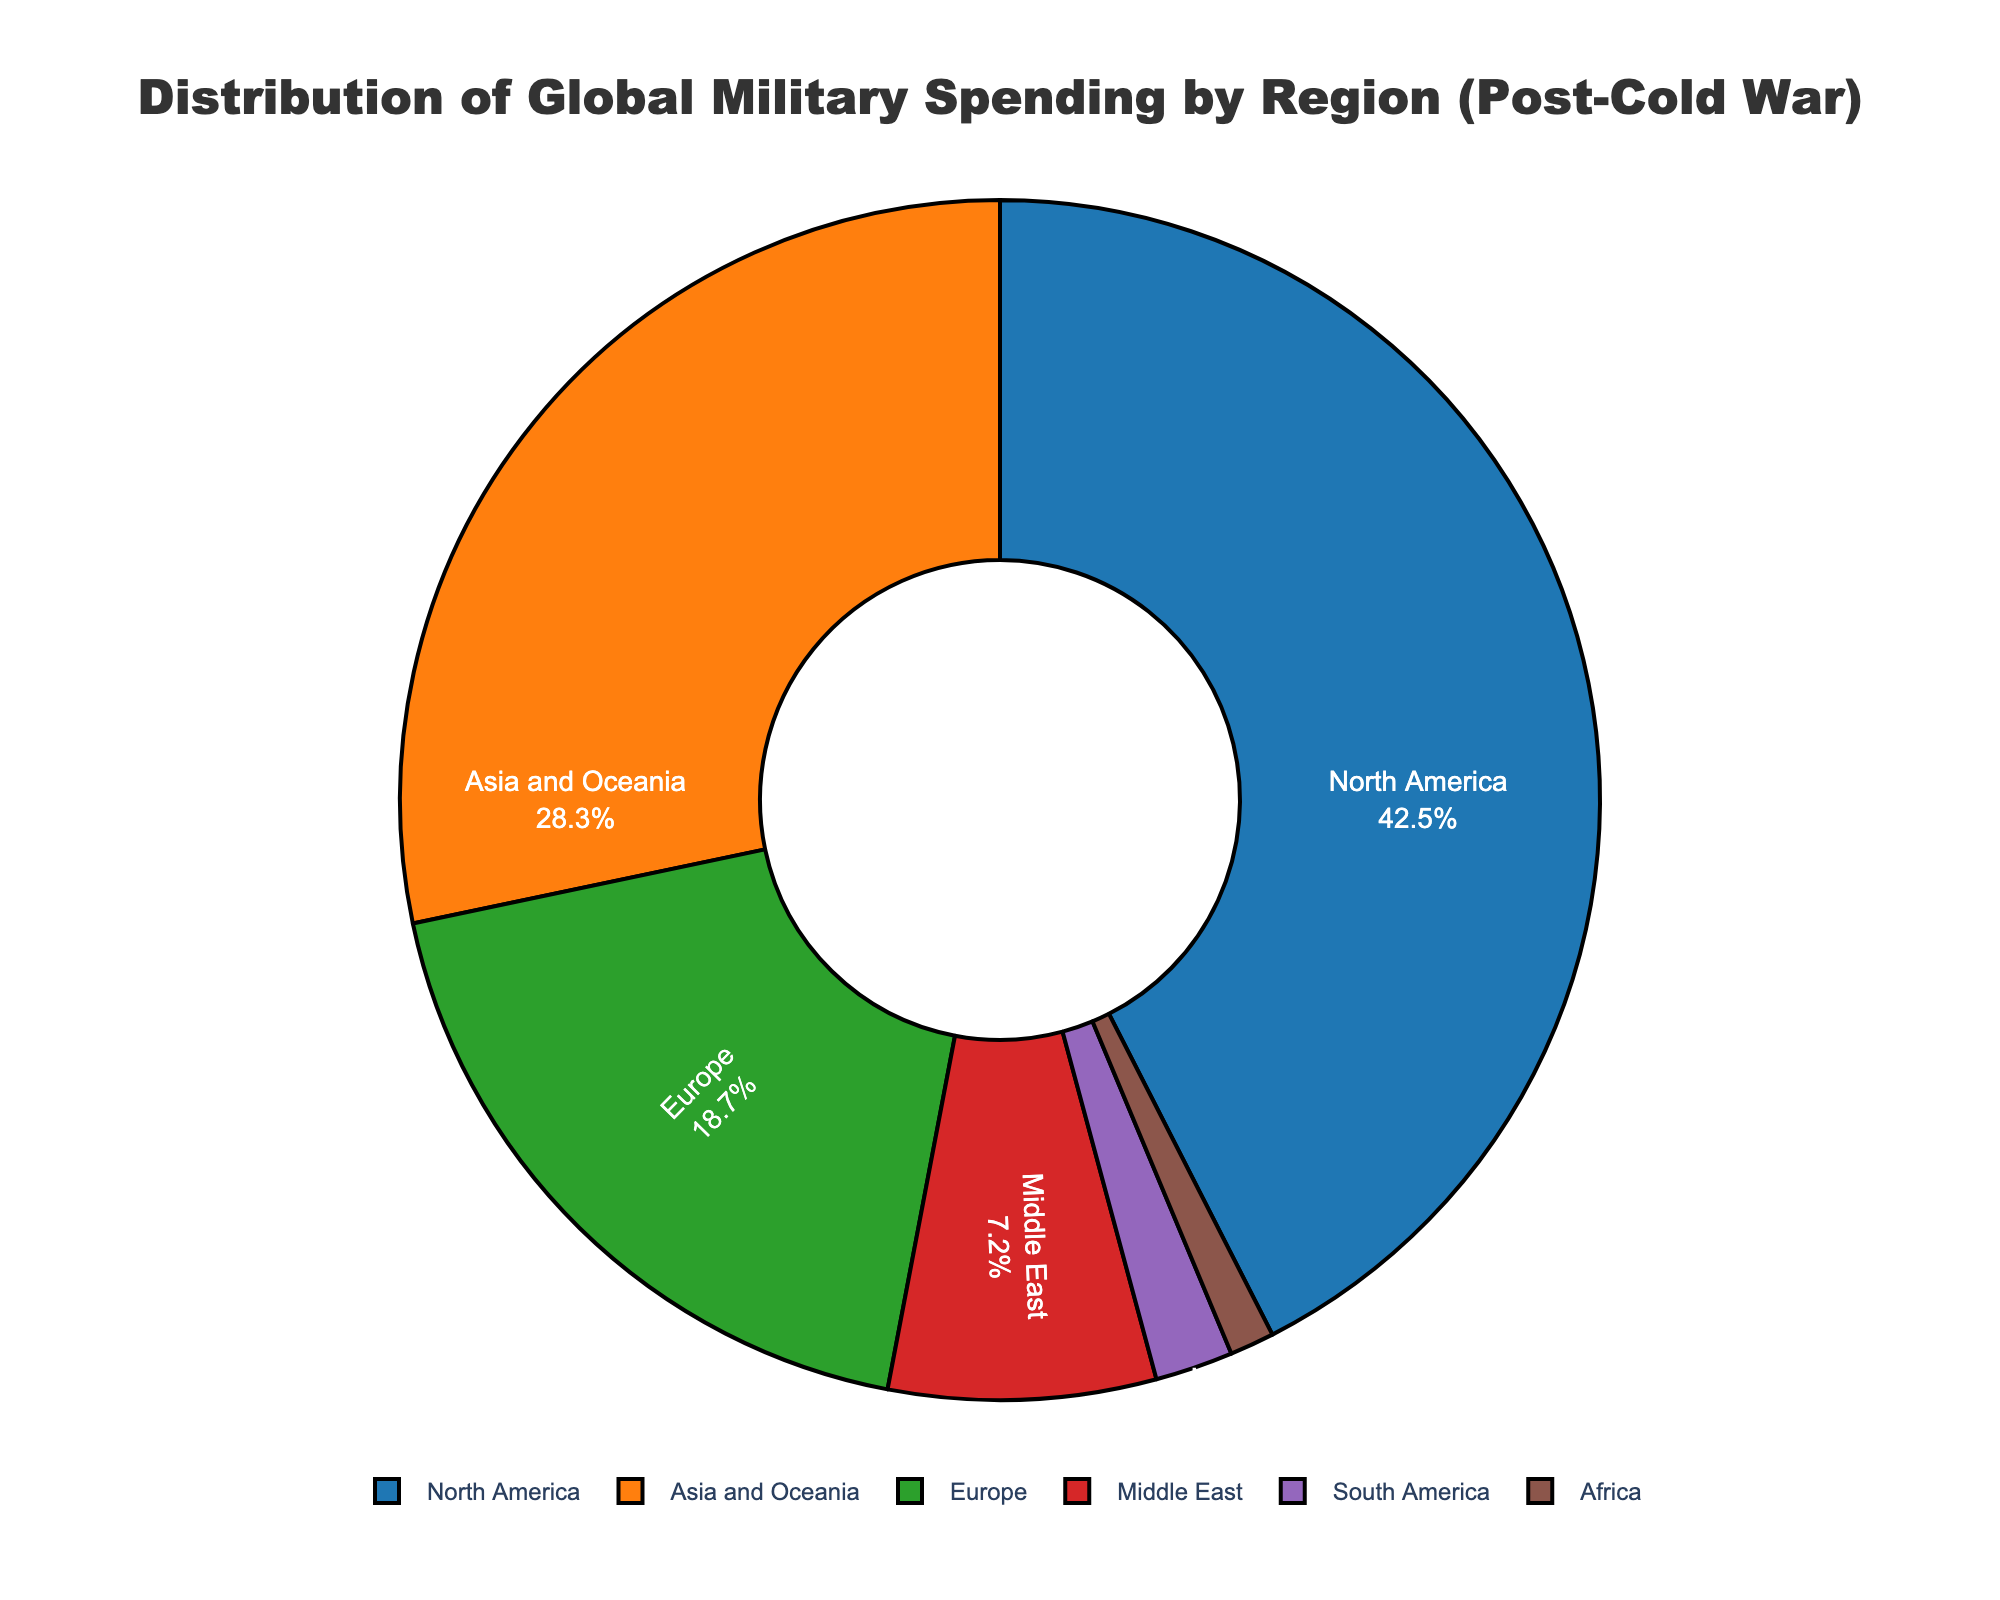Which region accounts for the largest share of global military spending? From the pie chart, the largest portion is represented by North America, which has a percentage of 42.5%. This is visually the largest segment.
Answer: North America What percentage of global military spending is attributed to Asia and Oceania? The chart displays the specific percentage for Asia and Oceania as 28.3%, visible in the segment of the pie chart labeled Asia and Oceania.
Answer: 28.3% How does Europe's share of global military spending compare to that of the Middle East? From the pie chart, Europe accounts for 18.7% while the Middle East accounts for 7.2%. Comparing these percentages visually and numerically, Europe's share is larger.
Answer: Europe's share is larger What is the combined percentage of global military spending for Africa, South America, and the Middle East? Adding the percentages from the pie chart: Africa (1.2%), South America (2.1%), and the Middle East (7.2%), the combined total is 1.2 + 2.1 + 7.2 = 10.5%.
Answer: 10.5% Which region has the smallest share of global military spending and what is the percentage? The smallest segment in the pie chart is Africa, which is specifically labeled with a percentage of 1.2%.
Answer: Africa, 1.2% Is the combined military spending for Europe and Asia and Oceania more than for North America? The percentages given are Europe 18.7% and Asia and Oceania 28.3%. Adding them together equals 18.7 + 28.3 = 47%. North America's share is 42.5%. Therefore, the combined share for Europe and Asia and Oceania is greater than North America's share.
Answer: Yes, combined share is more Which two regions together make up more than half of the global military spending? From the pie chart, North America (42.5%) and Asia and Oceania (28.3%) combined sum up to 42.5 + 28.3 = 70.8%, which is more than half of the total.
Answer: North America and Asia and Oceania By how much does North America's military spending exceed Europe's spending? North America's share is 42.5% and Europe's share is 18.7%. Subtracting Europe's share from North America's share gives 42.5 - 18.7 = 23.8%.
Answer: 23.8% What fraction of the total military spending is accounted for by regions outside of North America and Asia and Oceania? The combined share of North America and Asia and Oceania is 42.5% + 28.3% = 70.8%. Therefore, the rest is 100% - 70.8% = 29.2%.
Answer: 29.2% If Europe’s military spending were to increase by 10% of its current percentage, what would Europe's new share be? Europe's current share is 18.7%. Increasing this by 10% of 18.7% (which is 1.87%) results in a new share of 18.7% + 1.87% = 20.57%.
Answer: 20.57% 